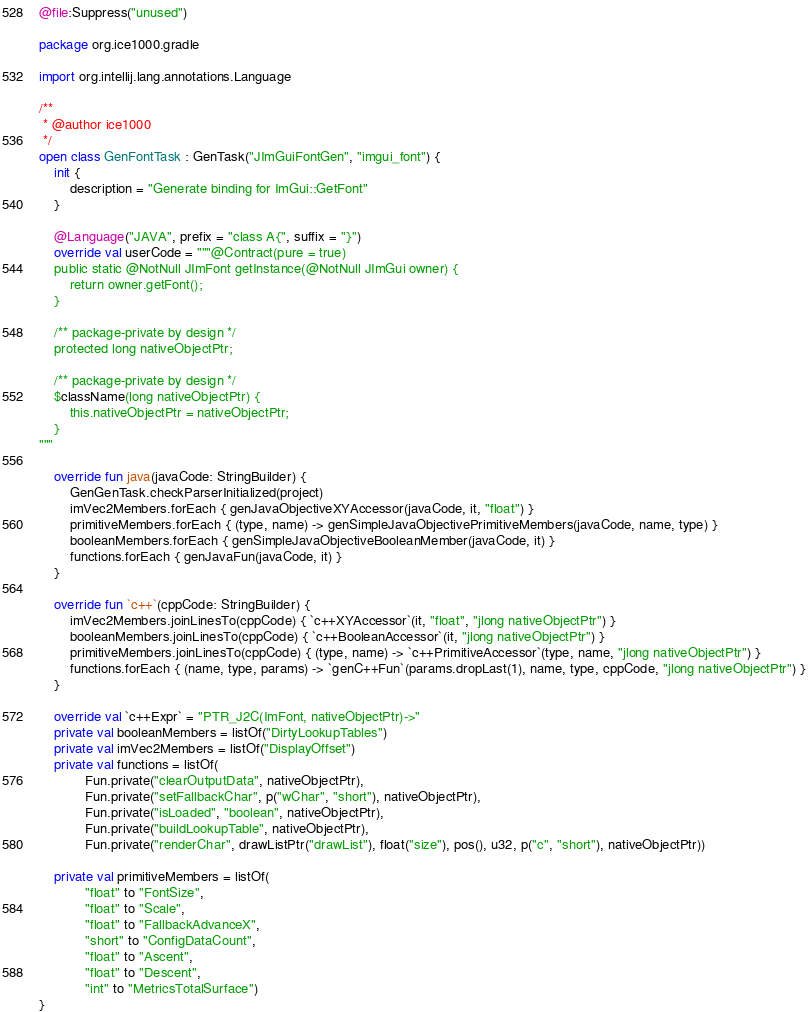<code> <loc_0><loc_0><loc_500><loc_500><_Kotlin_>@file:Suppress("unused")

package org.ice1000.gradle

import org.intellij.lang.annotations.Language

/**
 * @author ice1000
 */
open class GenFontTask : GenTask("JImGuiFontGen", "imgui_font") {
	init {
		description = "Generate binding for ImGui::GetFont"
	}

	@Language("JAVA", prefix = "class A{", suffix = "}")
	override val userCode = """@Contract(pure = true)
	public static @NotNull JImFont getInstance(@NotNull JImGui owner) {
		return owner.getFont();
	}

	/** package-private by design */
	protected long nativeObjectPtr;

	/** package-private by design */
	$className(long nativeObjectPtr) {
		this.nativeObjectPtr = nativeObjectPtr;
	}
"""

	override fun java(javaCode: StringBuilder) {
		GenGenTask.checkParserInitialized(project)
		imVec2Members.forEach { genJavaObjectiveXYAccessor(javaCode, it, "float") }
		primitiveMembers.forEach { (type, name) -> genSimpleJavaObjectivePrimitiveMembers(javaCode, name, type) }
		booleanMembers.forEach { genSimpleJavaObjectiveBooleanMember(javaCode, it) }
		functions.forEach { genJavaFun(javaCode, it) }
	}

	override fun `c++`(cppCode: StringBuilder) {
		imVec2Members.joinLinesTo(cppCode) { `c++XYAccessor`(it, "float", "jlong nativeObjectPtr") }
		booleanMembers.joinLinesTo(cppCode) { `c++BooleanAccessor`(it, "jlong nativeObjectPtr") }
		primitiveMembers.joinLinesTo(cppCode) { (type, name) -> `c++PrimitiveAccessor`(type, name, "jlong nativeObjectPtr") }
		functions.forEach { (name, type, params) -> `genC++Fun`(params.dropLast(1), name, type, cppCode, "jlong nativeObjectPtr") }
	}

	override val `c++Expr` = "PTR_J2C(ImFont, nativeObjectPtr)->"
	private val booleanMembers = listOf("DirtyLookupTables")
	private val imVec2Members = listOf("DisplayOffset")
	private val functions = listOf(
			Fun.private("clearOutputData", nativeObjectPtr),
			Fun.private("setFallbackChar", p("wChar", "short"), nativeObjectPtr),
			Fun.private("isLoaded", "boolean", nativeObjectPtr),
			Fun.private("buildLookupTable", nativeObjectPtr),
			Fun.private("renderChar", drawListPtr("drawList"), float("size"), pos(), u32, p("c", "short"), nativeObjectPtr))

	private val primitiveMembers = listOf(
			"float" to "FontSize",
			"float" to "Scale",
			"float" to "FallbackAdvanceX",
			"short" to "ConfigDataCount",
			"float" to "Ascent",
			"float" to "Descent",
			"int" to "MetricsTotalSurface")
}
</code> 